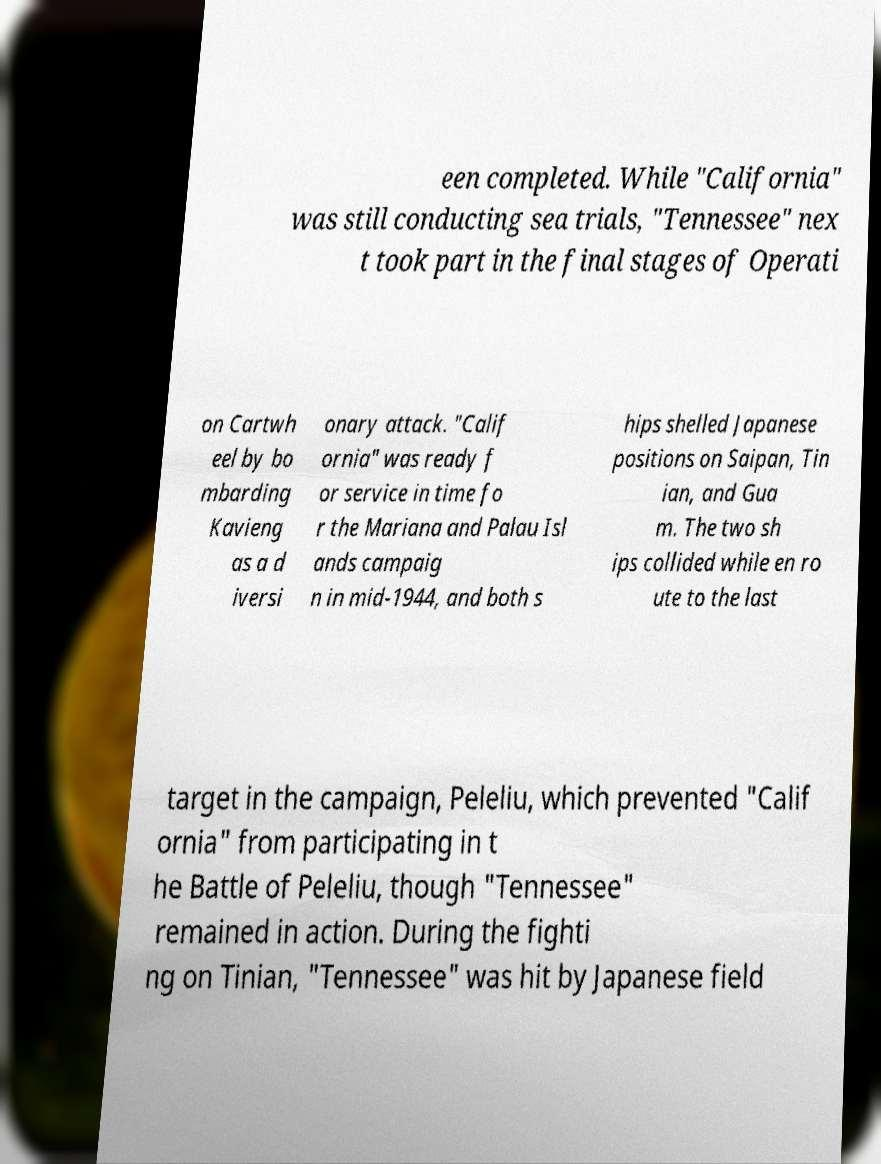Please identify and transcribe the text found in this image. een completed. While "California" was still conducting sea trials, "Tennessee" nex t took part in the final stages of Operati on Cartwh eel by bo mbarding Kavieng as a d iversi onary attack. "Calif ornia" was ready f or service in time fo r the Mariana and Palau Isl ands campaig n in mid-1944, and both s hips shelled Japanese positions on Saipan, Tin ian, and Gua m. The two sh ips collided while en ro ute to the last target in the campaign, Peleliu, which prevented "Calif ornia" from participating in t he Battle of Peleliu, though "Tennessee" remained in action. During the fighti ng on Tinian, "Tennessee" was hit by Japanese field 